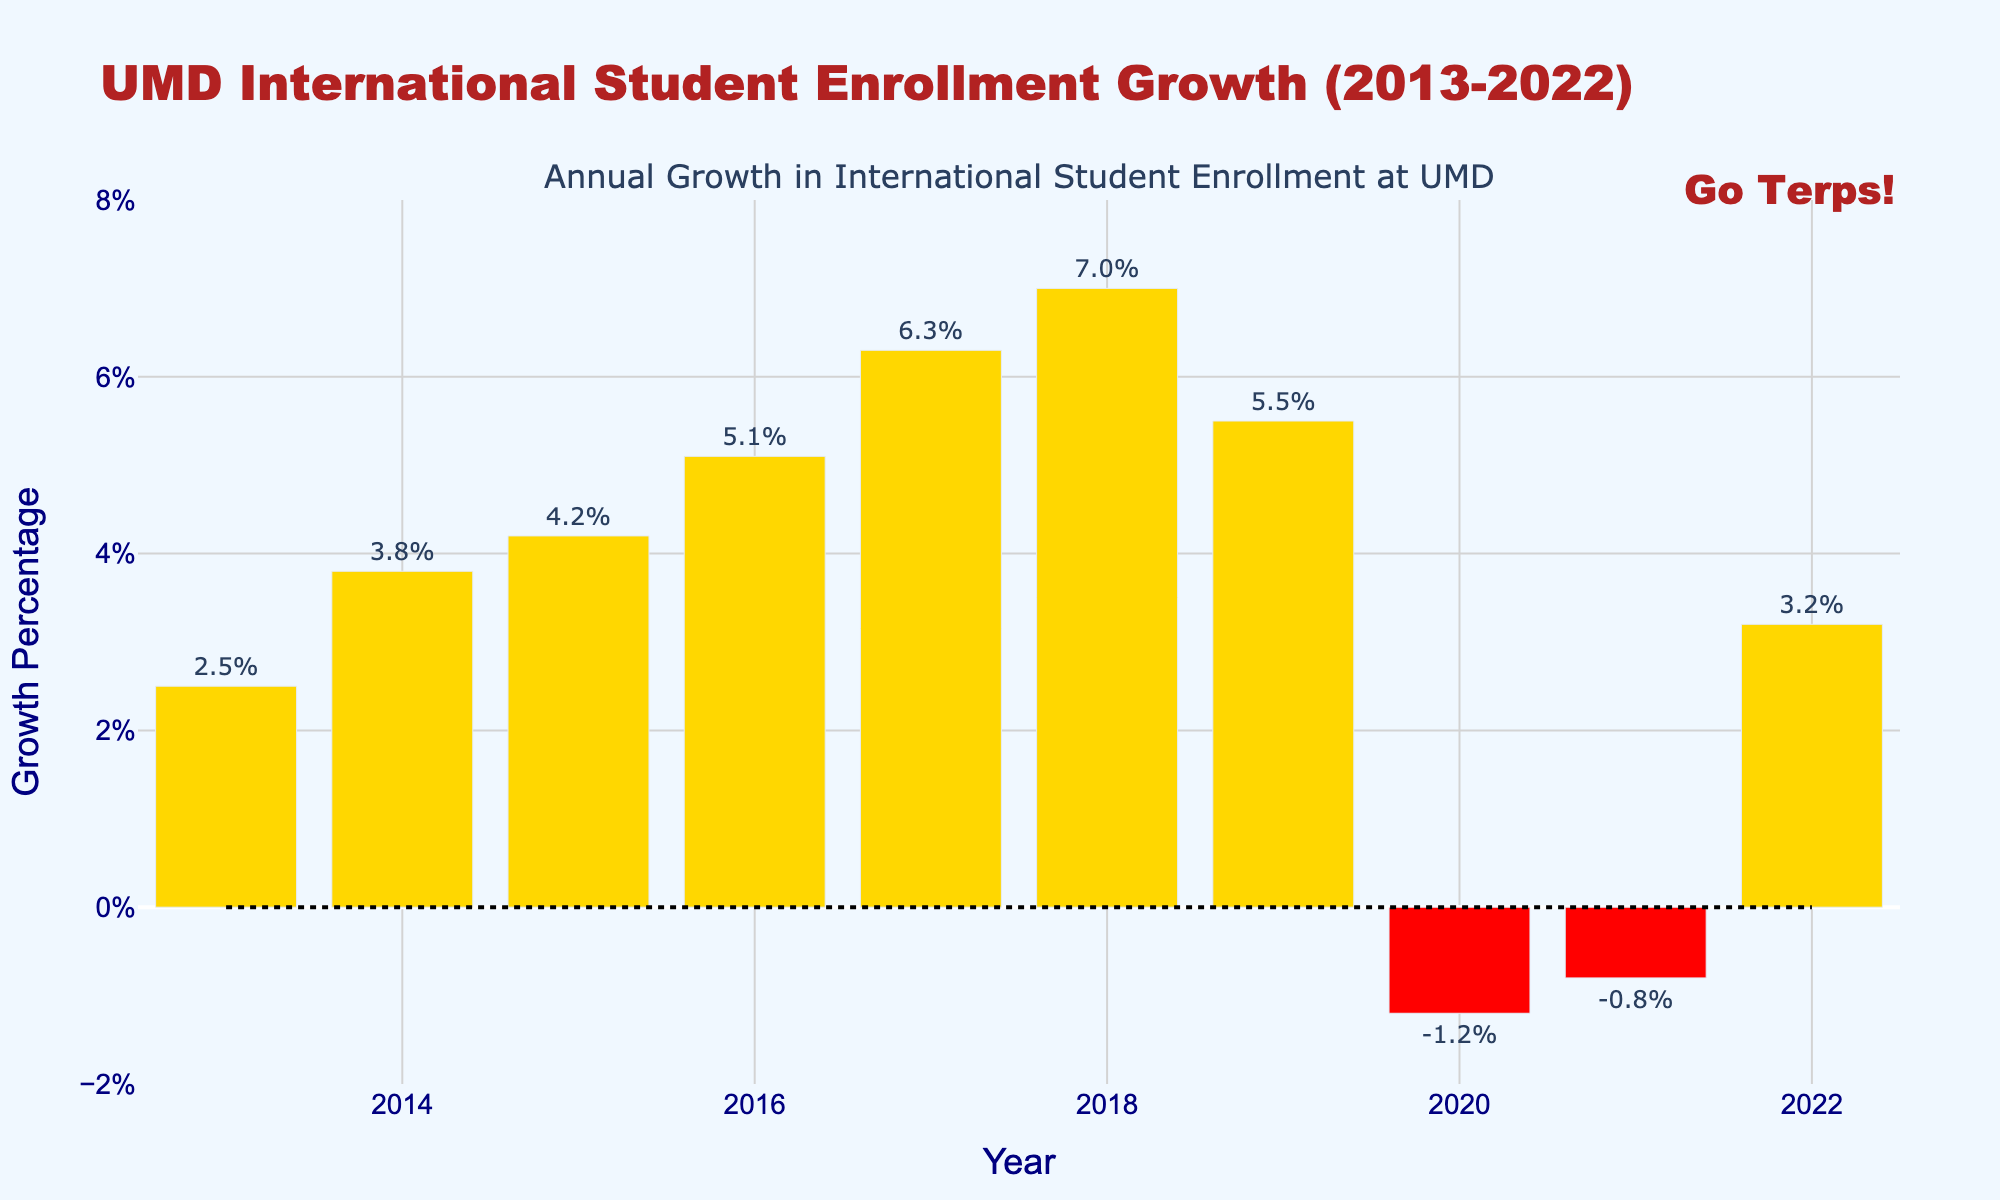What year had the highest growth percentage in international student enrollment? Look for the tallest bar in the figure. The highest growth percentage is indicated by the height of the bar for the year 2018.
Answer: 2018 Which years experienced a decline in international student enrollment growth? Identify the bars colored in red, as negative growth percentages are visually represented by these bars. The years with negative bars are 2020 and 2021.
Answer: 2020 and 2021 What is the average growth percentage from 2013 to 2022? Sum up the growth percentages for all the years and divide by the number of years (10). Calculation: (2.5 + 3.8 + 4.2 + 5.1 + 6.3 + 7.0 + 5.5 - 1.2 - 0.8 + 3.2) / 10 = 3.36
Answer: 3.4 By how much did the growth percentage change from 2019 to 2020? Subtract the growth percentage of 2020 from that of 2019. Calculation: 5.5 - (-1.2) = 6.7
Answer: 6.7 Which year showed the lowest positive growth percentage? Among the bars with positive heights (colored yellow), find the shortest one. The year 2013 has the lowest positive growth percentage of 2.5%.
Answer: 2013 What is the total growth percentage over the past decade (2013-2022), considering both positive and negative values? Sum up the growth percentages for all the years. Calculation: 2.5 + 3.8 + 4.2 + 5.1 + 6.3 + 7.0 + 5.5 - 1.2 - 0.8 + 3.2 = 35.6
Answer: 35.6 Compare the growth percentages of 2014 and 2015. Which year had a higher growth percentage and by how much? Subtract the growth percentage of 2014 from that of 2015. Calculation: 4.2 - 3.8 = 0.4. The year 2015 had a higher growth percentage by 0.4.
Answer: 2015 by 0.4 Which color represents negative growth percentages, and what are the corresponding years? Red bars represent the negative growth percentages. Identify the red bars to find the corresponding years, which are 2020 and 2021.
Answer: Red, 2020 and 2021 What's the difference between the highest and lowest growth percentages in this dataset? Subtract the lowest growth percentage (-1.2 in 2020) from the highest growth percentage (7.0 in 2018). Calculation: 7.0 - (-1.2) = 8.2
Answer: 8.2 